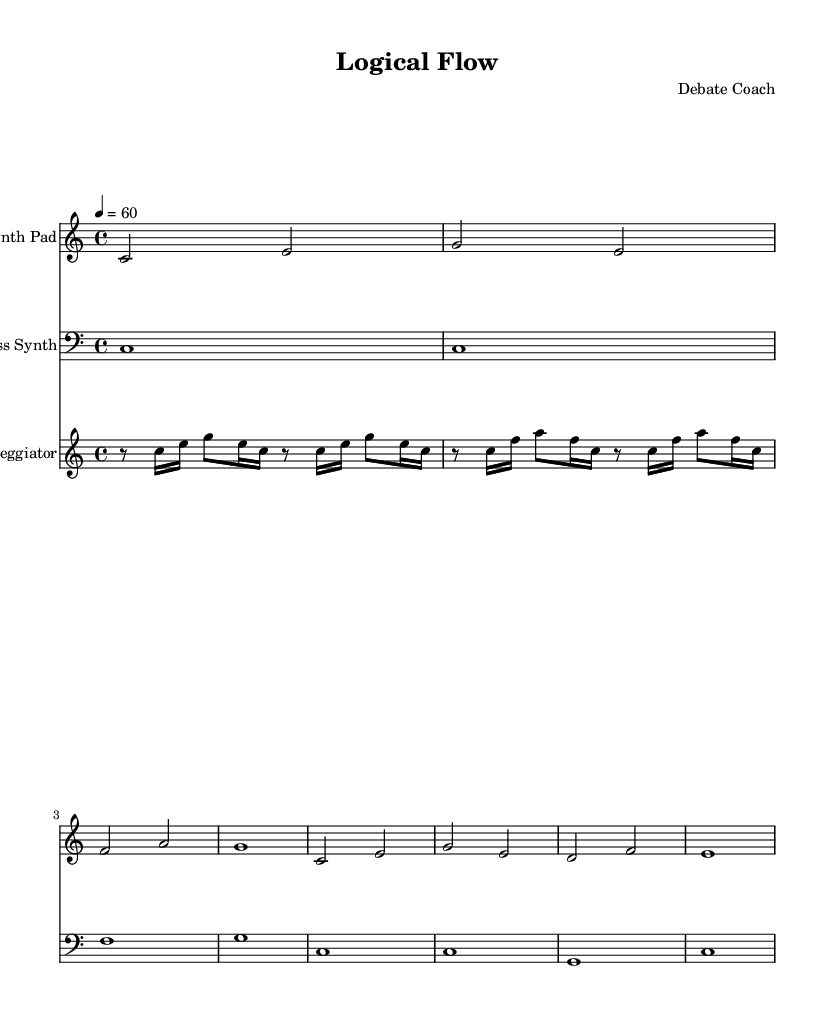What is the key signature of this music? The key signature indicated in the score is C major, which features no sharps or flats in its scale, making it easily identifiable.
Answer: C major What is the time signature of this music? The time signature visible in the sheet music is 4/4, meaning there are four beats per measure and the quarter note gets one beat.
Answer: 4/4 What is the tempo marking of this composition? The tempo indicated in the score is 60 beats per minute, which is reflected in the marking. This suggests a slow and steady pace for the performance.
Answer: 60 Which instrument plays the arpeggiation section? The specific section of the score labeled 'Arpeggiator' is performed on a synthesizer that features arpeggiated notes, recognizable by the repeated patterns of a single line.
Answer: Arpeggiator How many measures are present in the synth pad section? Counting the measures in the 'Synth Pad' section, we find that there are a total of eight measures indicated throughout the score.
Answer: Eight What is the rhythmic pattern of the bass synth? The 'Bass Synth' part showcases a simple rhythmic pattern where each measure consists of a whole note. This signifies sustained bass tones emphasizing the root notes.
Answer: Whole notes 